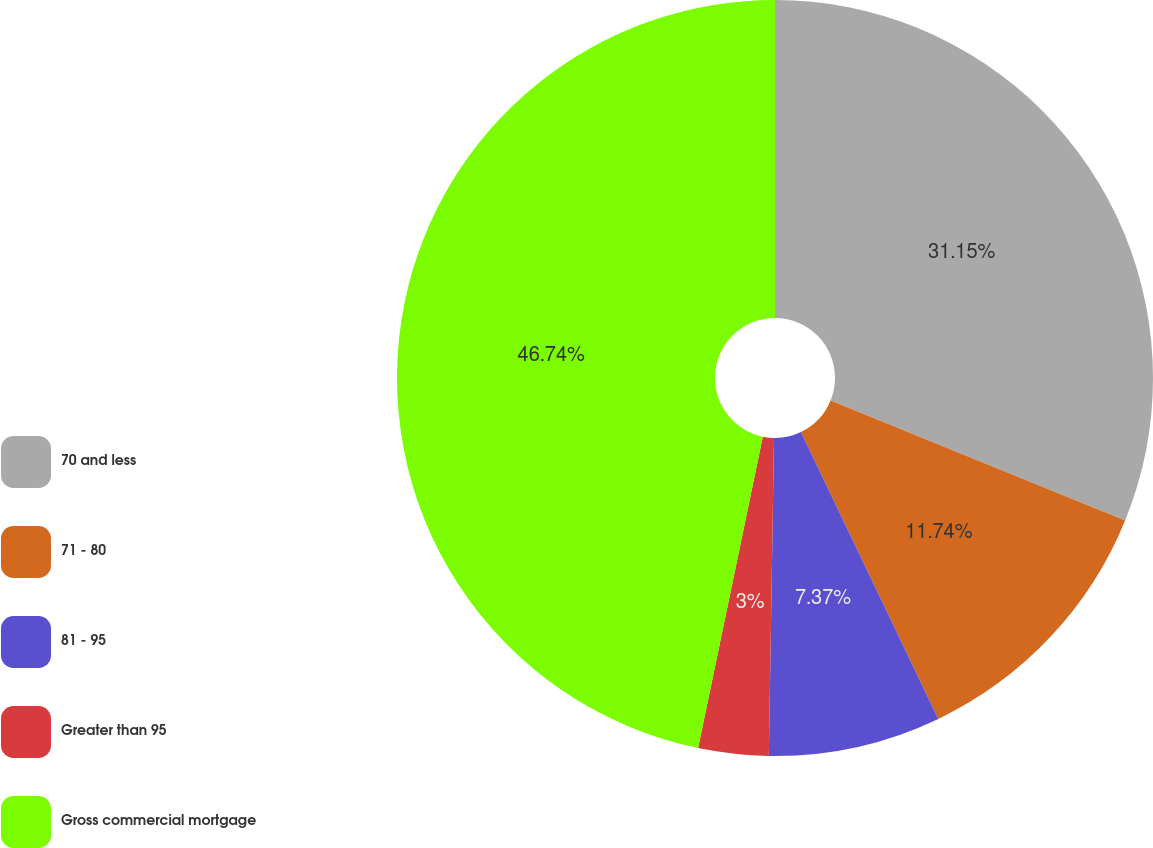<chart> <loc_0><loc_0><loc_500><loc_500><pie_chart><fcel>70 and less<fcel>71 - 80<fcel>81 - 95<fcel>Greater than 95<fcel>Gross commercial mortgage<nl><fcel>31.15%<fcel>11.74%<fcel>7.37%<fcel>3.0%<fcel>46.74%<nl></chart> 